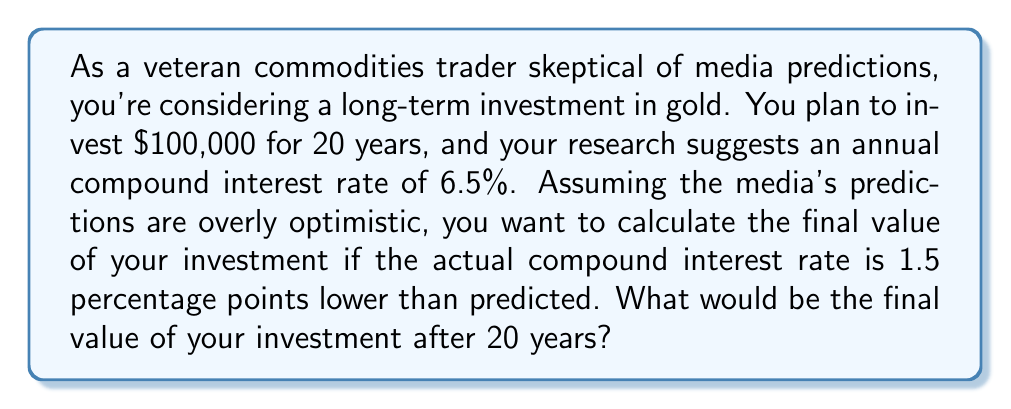Could you help me with this problem? Let's approach this step-by-step:

1) The predicted annual compound interest rate is 6.5%.
2) We need to calculate with a rate 1.5 percentage points lower: 6.5% - 1.5% = 5%.
3) We'll use the compound interest formula:
   $$A = P(1 + r)^n$$
   Where:
   $A$ = final amount
   $P$ = principal (initial investment)
   $r$ = annual interest rate (as a decimal)
   $n$ = number of years

4) Let's plug in our values:
   $P = 100,000$
   $r = 0.05$ (5% expressed as a decimal)
   $n = 20$

5) Now we calculate:
   $$A = 100,000(1 + 0.05)^{20}$$

6) Simplify:
   $$A = 100,000(1.05)^{20}$$

7) Using a calculator (as a trader would):
   $$A = 100,000 * 2.6532977$$
   $$A = 265,329.77$$

This result shows how compound interest can significantly grow an investment over time, even with a lower-than-predicted rate. It also demonstrates the importance of accurate rate predictions in long-term commodity investments.
Answer: $265,329.77 